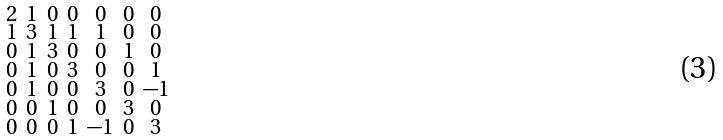Convert formula to latex. <formula><loc_0><loc_0><loc_500><loc_500>\begin{smallmatrix} 2 & 1 & 0 & 0 & 0 & 0 & 0 \\ 1 & 3 & 1 & 1 & 1 & 0 & 0 \\ 0 & 1 & 3 & 0 & 0 & 1 & 0 \\ 0 & 1 & 0 & 3 & 0 & 0 & 1 \\ 0 & 1 & 0 & 0 & 3 & 0 & - 1 \\ 0 & 0 & 1 & 0 & 0 & 3 & 0 \\ 0 & 0 & 0 & 1 & - 1 & 0 & 3 \end{smallmatrix}</formula> 